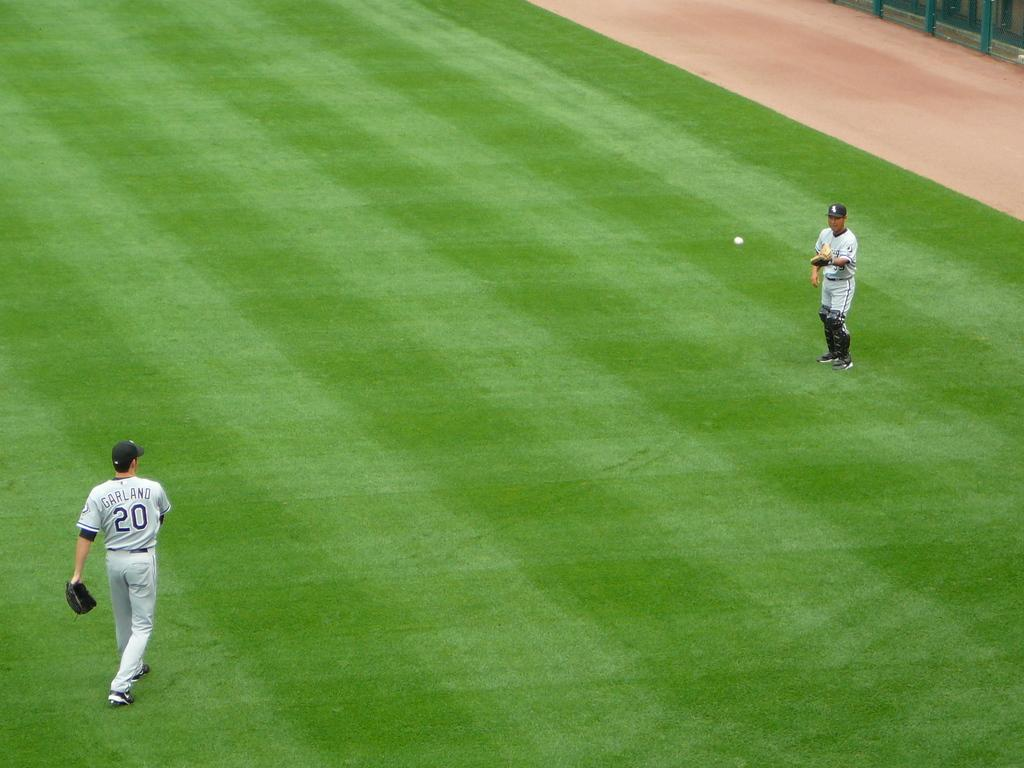<image>
Present a compact description of the photo's key features. a player that is wearing the number 20 on them 